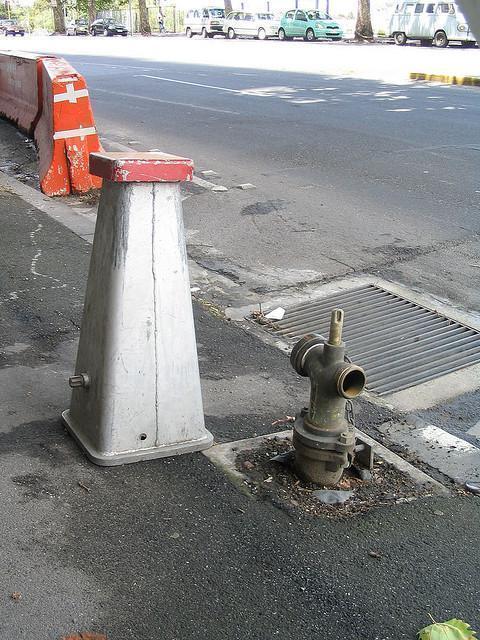What is on the floor?
Choose the correct response, then elucidate: 'Answer: answer
Rationale: rationale.'
Options: Eggs, cat, grate, ketchup. Answer: grate.
Rationale: A sewer grate is on the ground. What is on the floor?
Pick the correct solution from the four options below to address the question.
Options: Cow, grate, egg sandwich, pizza. Grate. 